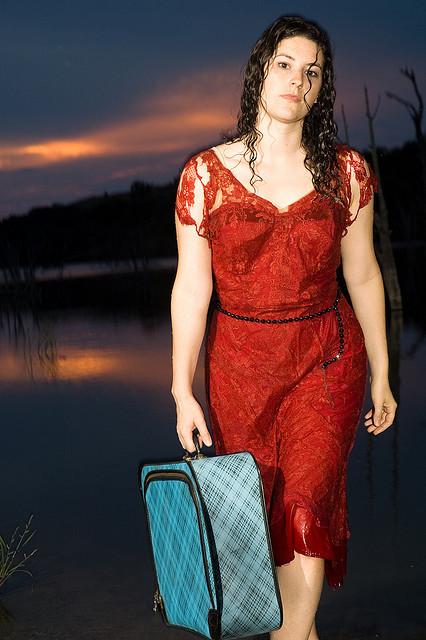Does the woman in red like sex with men?
Quick response, please. Yes. Is the woman wearing a belt?
Be succinct. Yes. What is the woman holding?
Give a very brief answer. Suitcase. 